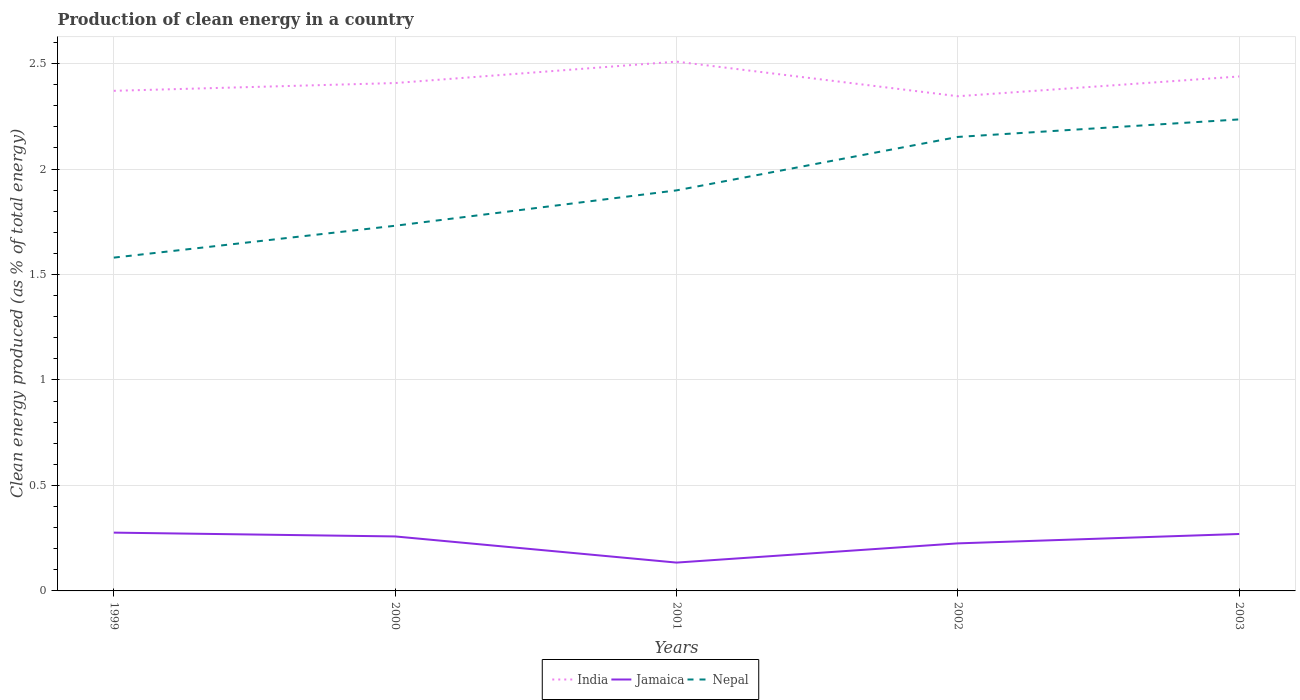How many different coloured lines are there?
Give a very brief answer. 3. Does the line corresponding to Jamaica intersect with the line corresponding to India?
Keep it short and to the point. No. Is the number of lines equal to the number of legend labels?
Offer a terse response. Yes. Across all years, what is the maximum percentage of clean energy produced in India?
Offer a terse response. 2.35. In which year was the percentage of clean energy produced in Jamaica maximum?
Offer a very short reply. 2001. What is the total percentage of clean energy produced in Jamaica in the graph?
Your answer should be compact. -0.14. What is the difference between the highest and the second highest percentage of clean energy produced in India?
Make the answer very short. 0.16. Is the percentage of clean energy produced in India strictly greater than the percentage of clean energy produced in Nepal over the years?
Keep it short and to the point. No. How many lines are there?
Make the answer very short. 3. How many years are there in the graph?
Give a very brief answer. 5. What is the difference between two consecutive major ticks on the Y-axis?
Ensure brevity in your answer.  0.5. Does the graph contain any zero values?
Offer a very short reply. No. Does the graph contain grids?
Your answer should be very brief. Yes. Where does the legend appear in the graph?
Keep it short and to the point. Bottom center. How are the legend labels stacked?
Ensure brevity in your answer.  Horizontal. What is the title of the graph?
Make the answer very short. Production of clean energy in a country. What is the label or title of the Y-axis?
Your answer should be very brief. Clean energy produced (as % of total energy). What is the Clean energy produced (as % of total energy) of India in 1999?
Give a very brief answer. 2.37. What is the Clean energy produced (as % of total energy) in Jamaica in 1999?
Your response must be concise. 0.28. What is the Clean energy produced (as % of total energy) of Nepal in 1999?
Your answer should be compact. 1.58. What is the Clean energy produced (as % of total energy) of India in 2000?
Provide a short and direct response. 2.41. What is the Clean energy produced (as % of total energy) of Jamaica in 2000?
Your answer should be compact. 0.26. What is the Clean energy produced (as % of total energy) in Nepal in 2000?
Your answer should be compact. 1.73. What is the Clean energy produced (as % of total energy) in India in 2001?
Offer a very short reply. 2.51. What is the Clean energy produced (as % of total energy) in Jamaica in 2001?
Your answer should be compact. 0.13. What is the Clean energy produced (as % of total energy) in Nepal in 2001?
Your answer should be very brief. 1.9. What is the Clean energy produced (as % of total energy) in India in 2002?
Provide a succinct answer. 2.35. What is the Clean energy produced (as % of total energy) of Jamaica in 2002?
Give a very brief answer. 0.23. What is the Clean energy produced (as % of total energy) in Nepal in 2002?
Your response must be concise. 2.15. What is the Clean energy produced (as % of total energy) in India in 2003?
Make the answer very short. 2.44. What is the Clean energy produced (as % of total energy) of Jamaica in 2003?
Ensure brevity in your answer.  0.27. What is the Clean energy produced (as % of total energy) in Nepal in 2003?
Provide a succinct answer. 2.24. Across all years, what is the maximum Clean energy produced (as % of total energy) of India?
Ensure brevity in your answer.  2.51. Across all years, what is the maximum Clean energy produced (as % of total energy) of Jamaica?
Your response must be concise. 0.28. Across all years, what is the maximum Clean energy produced (as % of total energy) in Nepal?
Give a very brief answer. 2.24. Across all years, what is the minimum Clean energy produced (as % of total energy) of India?
Provide a short and direct response. 2.35. Across all years, what is the minimum Clean energy produced (as % of total energy) in Jamaica?
Provide a short and direct response. 0.13. Across all years, what is the minimum Clean energy produced (as % of total energy) in Nepal?
Give a very brief answer. 1.58. What is the total Clean energy produced (as % of total energy) in India in the graph?
Offer a very short reply. 12.07. What is the total Clean energy produced (as % of total energy) of Jamaica in the graph?
Provide a short and direct response. 1.16. What is the total Clean energy produced (as % of total energy) of Nepal in the graph?
Make the answer very short. 9.6. What is the difference between the Clean energy produced (as % of total energy) of India in 1999 and that in 2000?
Keep it short and to the point. -0.04. What is the difference between the Clean energy produced (as % of total energy) in Jamaica in 1999 and that in 2000?
Provide a succinct answer. 0.02. What is the difference between the Clean energy produced (as % of total energy) of Nepal in 1999 and that in 2000?
Give a very brief answer. -0.15. What is the difference between the Clean energy produced (as % of total energy) in India in 1999 and that in 2001?
Keep it short and to the point. -0.14. What is the difference between the Clean energy produced (as % of total energy) in Jamaica in 1999 and that in 2001?
Make the answer very short. 0.14. What is the difference between the Clean energy produced (as % of total energy) of Nepal in 1999 and that in 2001?
Provide a short and direct response. -0.32. What is the difference between the Clean energy produced (as % of total energy) of India in 1999 and that in 2002?
Make the answer very short. 0.03. What is the difference between the Clean energy produced (as % of total energy) in Jamaica in 1999 and that in 2002?
Provide a succinct answer. 0.05. What is the difference between the Clean energy produced (as % of total energy) in Nepal in 1999 and that in 2002?
Provide a short and direct response. -0.57. What is the difference between the Clean energy produced (as % of total energy) in India in 1999 and that in 2003?
Provide a succinct answer. -0.07. What is the difference between the Clean energy produced (as % of total energy) of Jamaica in 1999 and that in 2003?
Offer a terse response. 0.01. What is the difference between the Clean energy produced (as % of total energy) of Nepal in 1999 and that in 2003?
Provide a short and direct response. -0.66. What is the difference between the Clean energy produced (as % of total energy) in India in 2000 and that in 2001?
Provide a succinct answer. -0.1. What is the difference between the Clean energy produced (as % of total energy) of Jamaica in 2000 and that in 2001?
Ensure brevity in your answer.  0.12. What is the difference between the Clean energy produced (as % of total energy) of Nepal in 2000 and that in 2001?
Your answer should be compact. -0.17. What is the difference between the Clean energy produced (as % of total energy) in India in 2000 and that in 2002?
Your answer should be compact. 0.06. What is the difference between the Clean energy produced (as % of total energy) in Jamaica in 2000 and that in 2002?
Give a very brief answer. 0.03. What is the difference between the Clean energy produced (as % of total energy) in Nepal in 2000 and that in 2002?
Offer a very short reply. -0.42. What is the difference between the Clean energy produced (as % of total energy) of India in 2000 and that in 2003?
Give a very brief answer. -0.03. What is the difference between the Clean energy produced (as % of total energy) of Jamaica in 2000 and that in 2003?
Your response must be concise. -0.01. What is the difference between the Clean energy produced (as % of total energy) of Nepal in 2000 and that in 2003?
Make the answer very short. -0.5. What is the difference between the Clean energy produced (as % of total energy) of India in 2001 and that in 2002?
Offer a very short reply. 0.16. What is the difference between the Clean energy produced (as % of total energy) in Jamaica in 2001 and that in 2002?
Your answer should be very brief. -0.09. What is the difference between the Clean energy produced (as % of total energy) in Nepal in 2001 and that in 2002?
Provide a short and direct response. -0.25. What is the difference between the Clean energy produced (as % of total energy) in India in 2001 and that in 2003?
Your answer should be very brief. 0.07. What is the difference between the Clean energy produced (as % of total energy) in Jamaica in 2001 and that in 2003?
Give a very brief answer. -0.14. What is the difference between the Clean energy produced (as % of total energy) of Nepal in 2001 and that in 2003?
Offer a terse response. -0.34. What is the difference between the Clean energy produced (as % of total energy) in India in 2002 and that in 2003?
Offer a terse response. -0.09. What is the difference between the Clean energy produced (as % of total energy) of Jamaica in 2002 and that in 2003?
Keep it short and to the point. -0.04. What is the difference between the Clean energy produced (as % of total energy) of Nepal in 2002 and that in 2003?
Your answer should be very brief. -0.08. What is the difference between the Clean energy produced (as % of total energy) of India in 1999 and the Clean energy produced (as % of total energy) of Jamaica in 2000?
Offer a terse response. 2.11. What is the difference between the Clean energy produced (as % of total energy) of India in 1999 and the Clean energy produced (as % of total energy) of Nepal in 2000?
Your answer should be very brief. 0.64. What is the difference between the Clean energy produced (as % of total energy) of Jamaica in 1999 and the Clean energy produced (as % of total energy) of Nepal in 2000?
Provide a short and direct response. -1.45. What is the difference between the Clean energy produced (as % of total energy) in India in 1999 and the Clean energy produced (as % of total energy) in Jamaica in 2001?
Provide a succinct answer. 2.24. What is the difference between the Clean energy produced (as % of total energy) in India in 1999 and the Clean energy produced (as % of total energy) in Nepal in 2001?
Provide a succinct answer. 0.47. What is the difference between the Clean energy produced (as % of total energy) of Jamaica in 1999 and the Clean energy produced (as % of total energy) of Nepal in 2001?
Make the answer very short. -1.62. What is the difference between the Clean energy produced (as % of total energy) in India in 1999 and the Clean energy produced (as % of total energy) in Jamaica in 2002?
Provide a succinct answer. 2.15. What is the difference between the Clean energy produced (as % of total energy) of India in 1999 and the Clean energy produced (as % of total energy) of Nepal in 2002?
Offer a terse response. 0.22. What is the difference between the Clean energy produced (as % of total energy) in Jamaica in 1999 and the Clean energy produced (as % of total energy) in Nepal in 2002?
Your response must be concise. -1.88. What is the difference between the Clean energy produced (as % of total energy) of India in 1999 and the Clean energy produced (as % of total energy) of Jamaica in 2003?
Provide a succinct answer. 2.1. What is the difference between the Clean energy produced (as % of total energy) in India in 1999 and the Clean energy produced (as % of total energy) in Nepal in 2003?
Keep it short and to the point. 0.14. What is the difference between the Clean energy produced (as % of total energy) of Jamaica in 1999 and the Clean energy produced (as % of total energy) of Nepal in 2003?
Offer a very short reply. -1.96. What is the difference between the Clean energy produced (as % of total energy) in India in 2000 and the Clean energy produced (as % of total energy) in Jamaica in 2001?
Keep it short and to the point. 2.27. What is the difference between the Clean energy produced (as % of total energy) of India in 2000 and the Clean energy produced (as % of total energy) of Nepal in 2001?
Your answer should be compact. 0.51. What is the difference between the Clean energy produced (as % of total energy) in Jamaica in 2000 and the Clean energy produced (as % of total energy) in Nepal in 2001?
Provide a succinct answer. -1.64. What is the difference between the Clean energy produced (as % of total energy) in India in 2000 and the Clean energy produced (as % of total energy) in Jamaica in 2002?
Make the answer very short. 2.18. What is the difference between the Clean energy produced (as % of total energy) of India in 2000 and the Clean energy produced (as % of total energy) of Nepal in 2002?
Provide a short and direct response. 0.26. What is the difference between the Clean energy produced (as % of total energy) in Jamaica in 2000 and the Clean energy produced (as % of total energy) in Nepal in 2002?
Make the answer very short. -1.89. What is the difference between the Clean energy produced (as % of total energy) of India in 2000 and the Clean energy produced (as % of total energy) of Jamaica in 2003?
Keep it short and to the point. 2.14. What is the difference between the Clean energy produced (as % of total energy) in India in 2000 and the Clean energy produced (as % of total energy) in Nepal in 2003?
Provide a short and direct response. 0.17. What is the difference between the Clean energy produced (as % of total energy) in Jamaica in 2000 and the Clean energy produced (as % of total energy) in Nepal in 2003?
Provide a succinct answer. -1.98. What is the difference between the Clean energy produced (as % of total energy) in India in 2001 and the Clean energy produced (as % of total energy) in Jamaica in 2002?
Offer a terse response. 2.28. What is the difference between the Clean energy produced (as % of total energy) in India in 2001 and the Clean energy produced (as % of total energy) in Nepal in 2002?
Your answer should be very brief. 0.36. What is the difference between the Clean energy produced (as % of total energy) in Jamaica in 2001 and the Clean energy produced (as % of total energy) in Nepal in 2002?
Give a very brief answer. -2.02. What is the difference between the Clean energy produced (as % of total energy) of India in 2001 and the Clean energy produced (as % of total energy) of Jamaica in 2003?
Make the answer very short. 2.24. What is the difference between the Clean energy produced (as % of total energy) of India in 2001 and the Clean energy produced (as % of total energy) of Nepal in 2003?
Your response must be concise. 0.27. What is the difference between the Clean energy produced (as % of total energy) of Jamaica in 2001 and the Clean energy produced (as % of total energy) of Nepal in 2003?
Offer a terse response. -2.1. What is the difference between the Clean energy produced (as % of total energy) in India in 2002 and the Clean energy produced (as % of total energy) in Jamaica in 2003?
Your answer should be very brief. 2.08. What is the difference between the Clean energy produced (as % of total energy) in India in 2002 and the Clean energy produced (as % of total energy) in Nepal in 2003?
Make the answer very short. 0.11. What is the difference between the Clean energy produced (as % of total energy) in Jamaica in 2002 and the Clean energy produced (as % of total energy) in Nepal in 2003?
Ensure brevity in your answer.  -2.01. What is the average Clean energy produced (as % of total energy) in India per year?
Provide a short and direct response. 2.41. What is the average Clean energy produced (as % of total energy) in Jamaica per year?
Provide a succinct answer. 0.23. What is the average Clean energy produced (as % of total energy) of Nepal per year?
Your answer should be very brief. 1.92. In the year 1999, what is the difference between the Clean energy produced (as % of total energy) of India and Clean energy produced (as % of total energy) of Jamaica?
Offer a terse response. 2.09. In the year 1999, what is the difference between the Clean energy produced (as % of total energy) in India and Clean energy produced (as % of total energy) in Nepal?
Keep it short and to the point. 0.79. In the year 1999, what is the difference between the Clean energy produced (as % of total energy) of Jamaica and Clean energy produced (as % of total energy) of Nepal?
Provide a succinct answer. -1.3. In the year 2000, what is the difference between the Clean energy produced (as % of total energy) of India and Clean energy produced (as % of total energy) of Jamaica?
Your answer should be very brief. 2.15. In the year 2000, what is the difference between the Clean energy produced (as % of total energy) of India and Clean energy produced (as % of total energy) of Nepal?
Your answer should be very brief. 0.68. In the year 2000, what is the difference between the Clean energy produced (as % of total energy) in Jamaica and Clean energy produced (as % of total energy) in Nepal?
Your response must be concise. -1.47. In the year 2001, what is the difference between the Clean energy produced (as % of total energy) in India and Clean energy produced (as % of total energy) in Jamaica?
Your answer should be compact. 2.37. In the year 2001, what is the difference between the Clean energy produced (as % of total energy) of India and Clean energy produced (as % of total energy) of Nepal?
Your answer should be compact. 0.61. In the year 2001, what is the difference between the Clean energy produced (as % of total energy) of Jamaica and Clean energy produced (as % of total energy) of Nepal?
Keep it short and to the point. -1.76. In the year 2002, what is the difference between the Clean energy produced (as % of total energy) of India and Clean energy produced (as % of total energy) of Jamaica?
Give a very brief answer. 2.12. In the year 2002, what is the difference between the Clean energy produced (as % of total energy) of India and Clean energy produced (as % of total energy) of Nepal?
Offer a very short reply. 0.19. In the year 2002, what is the difference between the Clean energy produced (as % of total energy) of Jamaica and Clean energy produced (as % of total energy) of Nepal?
Your answer should be very brief. -1.93. In the year 2003, what is the difference between the Clean energy produced (as % of total energy) in India and Clean energy produced (as % of total energy) in Jamaica?
Provide a short and direct response. 2.17. In the year 2003, what is the difference between the Clean energy produced (as % of total energy) in India and Clean energy produced (as % of total energy) in Nepal?
Keep it short and to the point. 0.2. In the year 2003, what is the difference between the Clean energy produced (as % of total energy) in Jamaica and Clean energy produced (as % of total energy) in Nepal?
Your response must be concise. -1.97. What is the ratio of the Clean energy produced (as % of total energy) in India in 1999 to that in 2000?
Offer a terse response. 0.98. What is the ratio of the Clean energy produced (as % of total energy) of Jamaica in 1999 to that in 2000?
Provide a short and direct response. 1.07. What is the ratio of the Clean energy produced (as % of total energy) of Nepal in 1999 to that in 2000?
Your answer should be compact. 0.91. What is the ratio of the Clean energy produced (as % of total energy) of India in 1999 to that in 2001?
Offer a very short reply. 0.94. What is the ratio of the Clean energy produced (as % of total energy) in Jamaica in 1999 to that in 2001?
Keep it short and to the point. 2.06. What is the ratio of the Clean energy produced (as % of total energy) in Nepal in 1999 to that in 2001?
Provide a succinct answer. 0.83. What is the ratio of the Clean energy produced (as % of total energy) in India in 1999 to that in 2002?
Your answer should be compact. 1.01. What is the ratio of the Clean energy produced (as % of total energy) in Jamaica in 1999 to that in 2002?
Offer a very short reply. 1.23. What is the ratio of the Clean energy produced (as % of total energy) of Nepal in 1999 to that in 2002?
Your answer should be compact. 0.73. What is the ratio of the Clean energy produced (as % of total energy) in India in 1999 to that in 2003?
Your response must be concise. 0.97. What is the ratio of the Clean energy produced (as % of total energy) of Jamaica in 1999 to that in 2003?
Give a very brief answer. 1.02. What is the ratio of the Clean energy produced (as % of total energy) in Nepal in 1999 to that in 2003?
Your answer should be compact. 0.71. What is the ratio of the Clean energy produced (as % of total energy) of India in 2000 to that in 2001?
Make the answer very short. 0.96. What is the ratio of the Clean energy produced (as % of total energy) in Jamaica in 2000 to that in 2001?
Ensure brevity in your answer.  1.92. What is the ratio of the Clean energy produced (as % of total energy) of Nepal in 2000 to that in 2001?
Your answer should be very brief. 0.91. What is the ratio of the Clean energy produced (as % of total energy) of India in 2000 to that in 2002?
Offer a terse response. 1.03. What is the ratio of the Clean energy produced (as % of total energy) in Jamaica in 2000 to that in 2002?
Offer a terse response. 1.15. What is the ratio of the Clean energy produced (as % of total energy) of Nepal in 2000 to that in 2002?
Your answer should be compact. 0.8. What is the ratio of the Clean energy produced (as % of total energy) in India in 2000 to that in 2003?
Give a very brief answer. 0.99. What is the ratio of the Clean energy produced (as % of total energy) in Jamaica in 2000 to that in 2003?
Keep it short and to the point. 0.96. What is the ratio of the Clean energy produced (as % of total energy) of Nepal in 2000 to that in 2003?
Give a very brief answer. 0.77. What is the ratio of the Clean energy produced (as % of total energy) in India in 2001 to that in 2002?
Provide a succinct answer. 1.07. What is the ratio of the Clean energy produced (as % of total energy) in Jamaica in 2001 to that in 2002?
Your response must be concise. 0.6. What is the ratio of the Clean energy produced (as % of total energy) of Nepal in 2001 to that in 2002?
Your answer should be compact. 0.88. What is the ratio of the Clean energy produced (as % of total energy) of India in 2001 to that in 2003?
Your answer should be very brief. 1.03. What is the ratio of the Clean energy produced (as % of total energy) of Jamaica in 2001 to that in 2003?
Ensure brevity in your answer.  0.5. What is the ratio of the Clean energy produced (as % of total energy) in Nepal in 2001 to that in 2003?
Provide a succinct answer. 0.85. What is the ratio of the Clean energy produced (as % of total energy) of India in 2002 to that in 2003?
Ensure brevity in your answer.  0.96. What is the ratio of the Clean energy produced (as % of total energy) of Jamaica in 2002 to that in 2003?
Provide a short and direct response. 0.84. What is the ratio of the Clean energy produced (as % of total energy) of Nepal in 2002 to that in 2003?
Provide a succinct answer. 0.96. What is the difference between the highest and the second highest Clean energy produced (as % of total energy) of India?
Offer a very short reply. 0.07. What is the difference between the highest and the second highest Clean energy produced (as % of total energy) of Jamaica?
Provide a short and direct response. 0.01. What is the difference between the highest and the second highest Clean energy produced (as % of total energy) of Nepal?
Provide a succinct answer. 0.08. What is the difference between the highest and the lowest Clean energy produced (as % of total energy) of India?
Offer a terse response. 0.16. What is the difference between the highest and the lowest Clean energy produced (as % of total energy) of Jamaica?
Ensure brevity in your answer.  0.14. What is the difference between the highest and the lowest Clean energy produced (as % of total energy) in Nepal?
Provide a succinct answer. 0.66. 